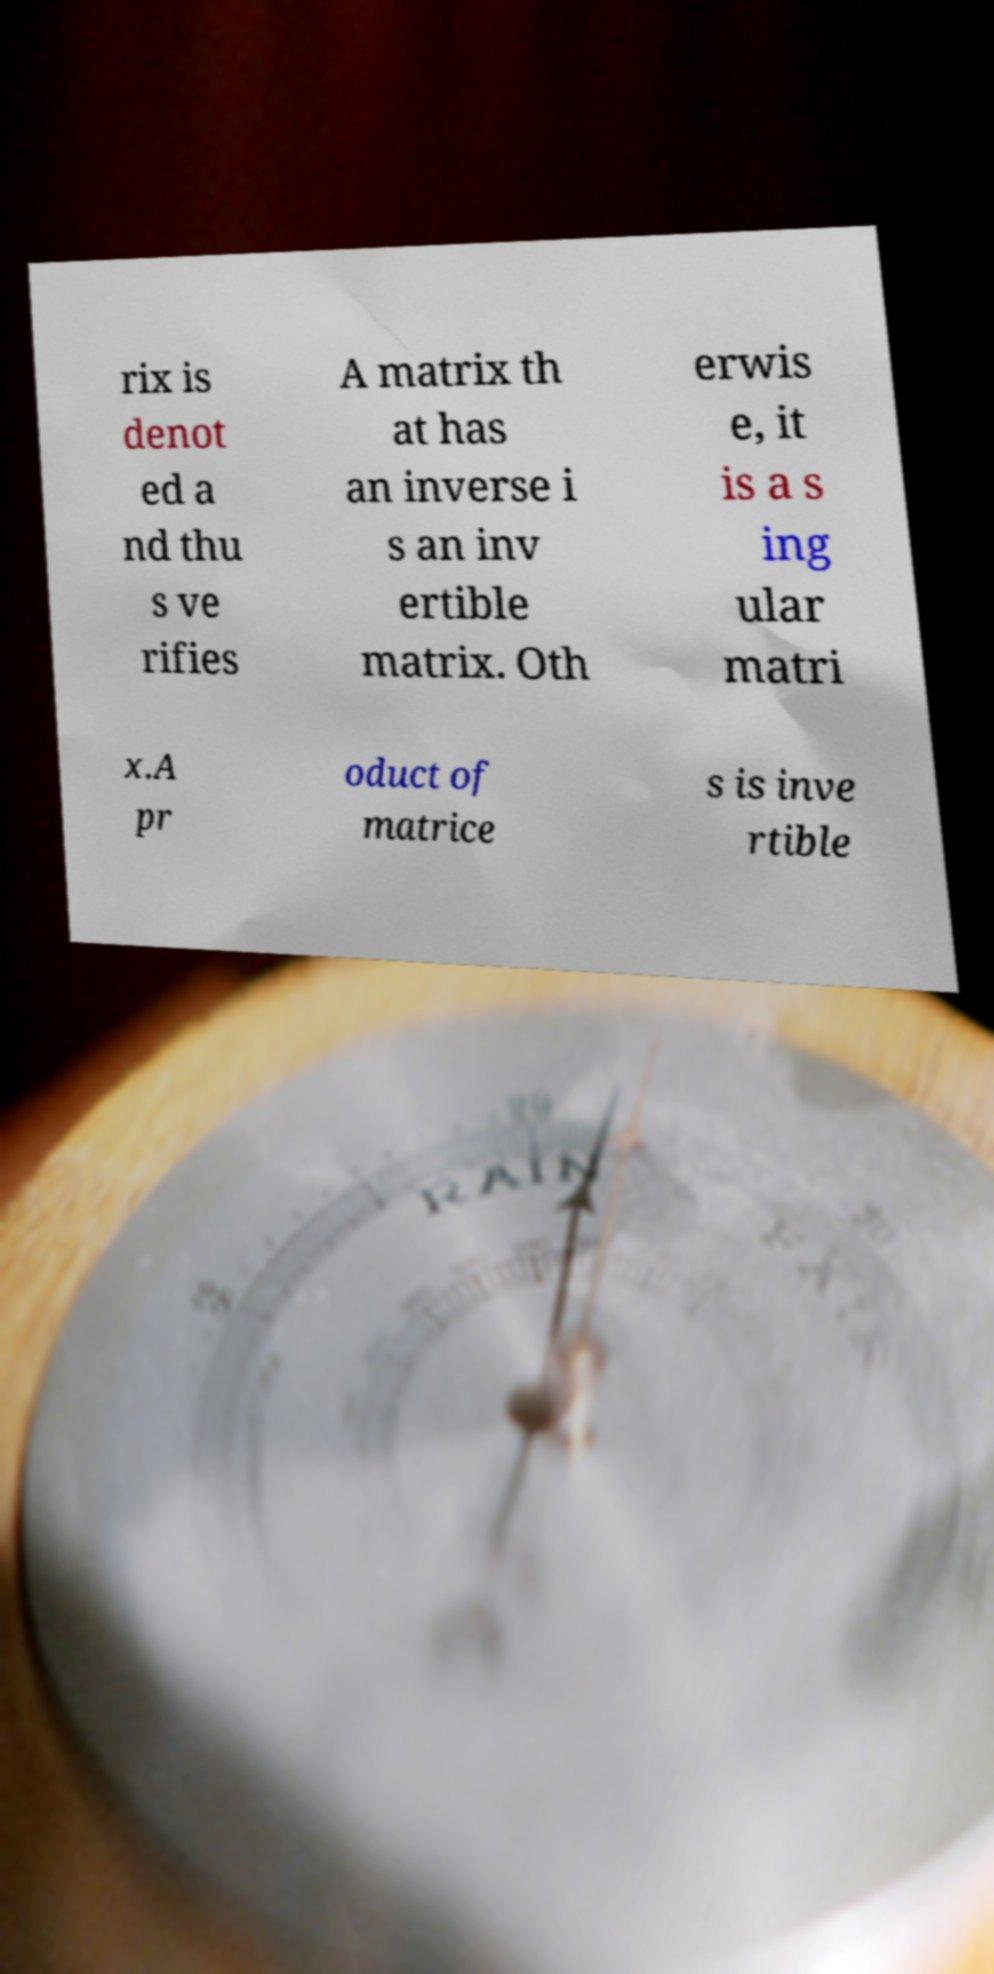I need the written content from this picture converted into text. Can you do that? rix is denot ed a nd thu s ve rifies A matrix th at has an inverse i s an inv ertible matrix. Oth erwis e, it is a s ing ular matri x.A pr oduct of matrice s is inve rtible 